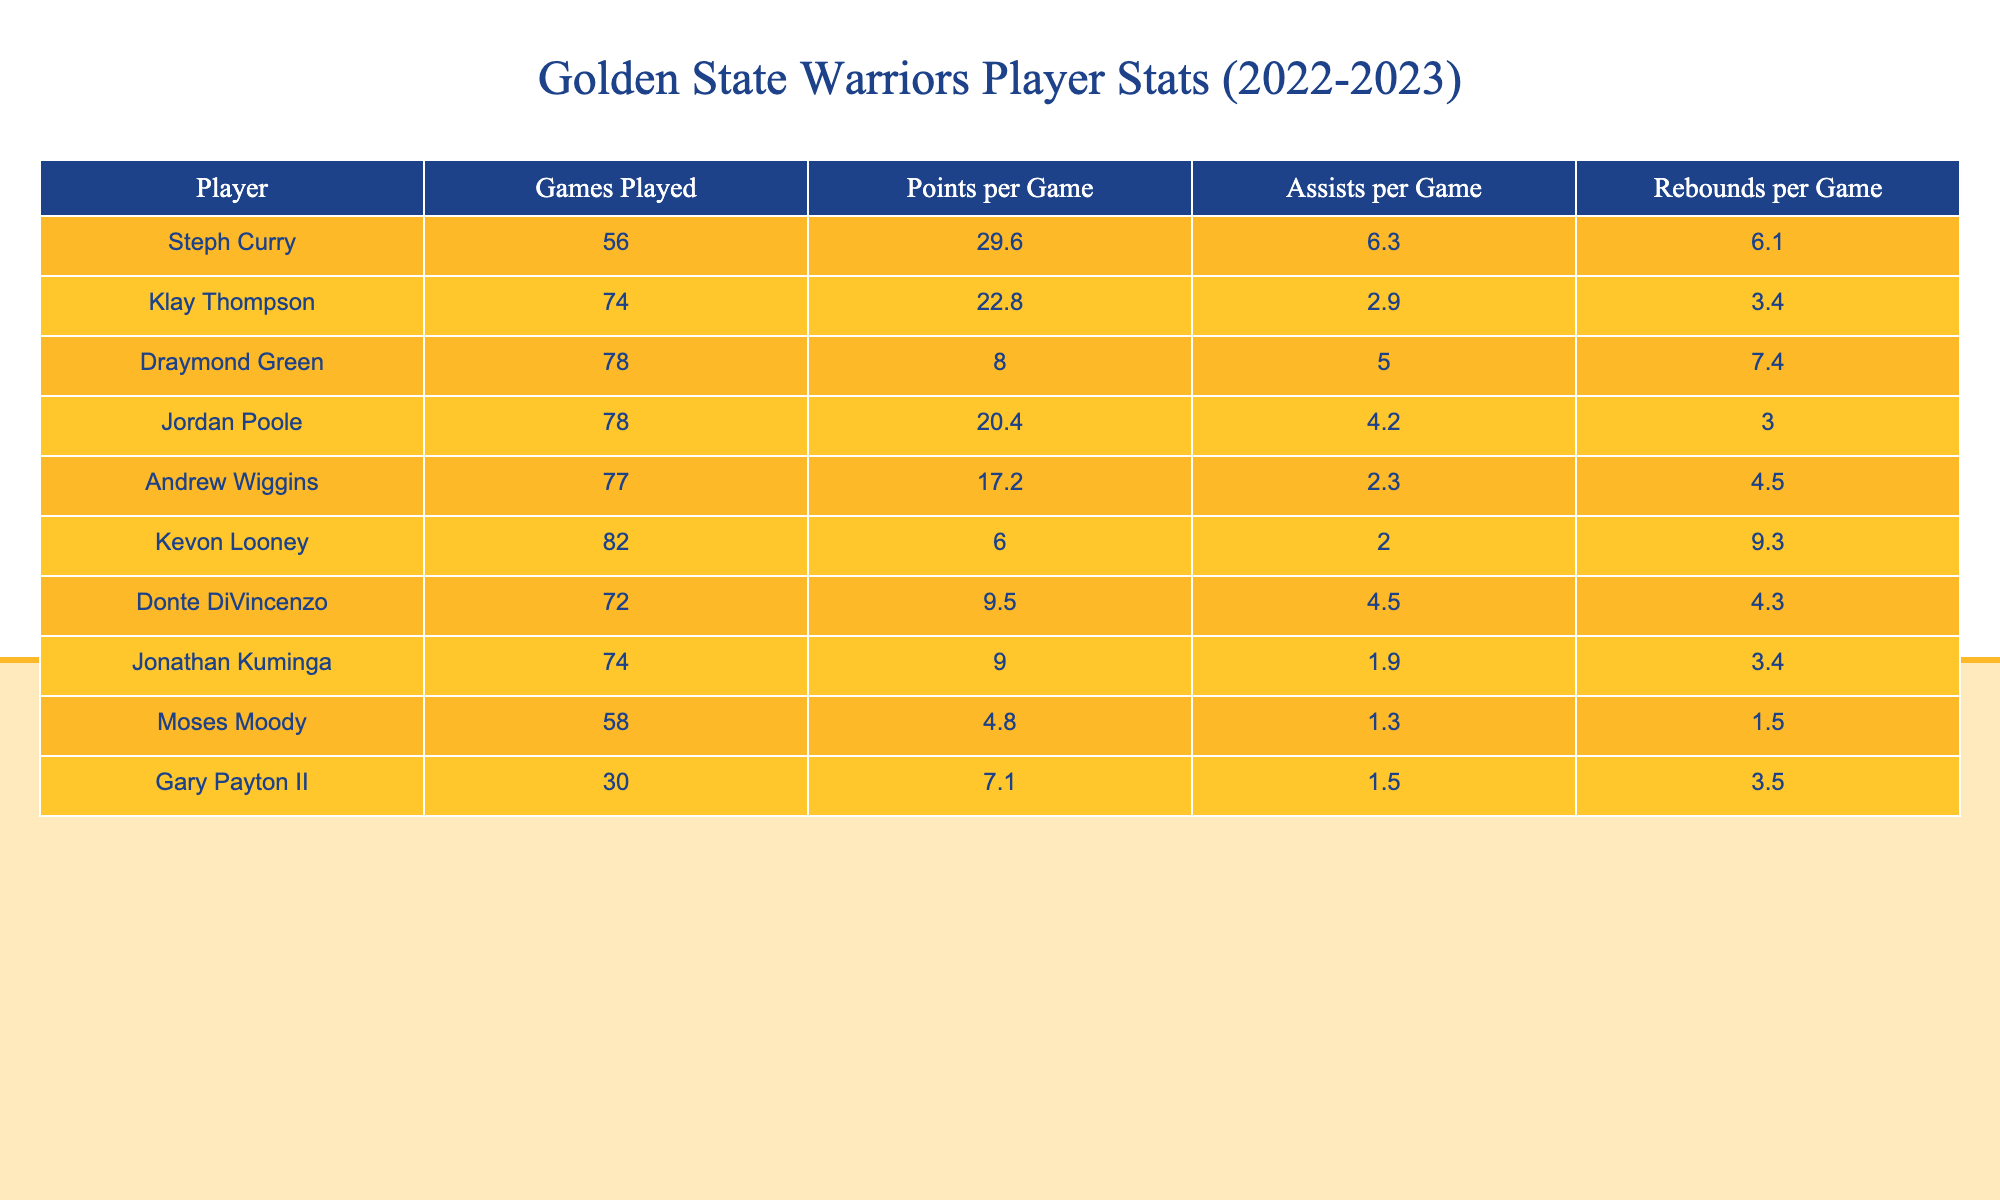What is Steph Curry's points per game during the 2022-2023 season? By looking at the table, Steph Curry's points per game is listed in the corresponding row under the "Points per Game" column. The value is 29.6.
Answer: 29.6 How many games did Klay Thompson play in the 2022-2023 season? In the table, Klay Thompson's row shows the number of games played under the "Games Played" column. The value is 74.
Answer: 74 Who had the highest assists per game in the season? To find the player with the highest assists per game, we compare the values in the "Assists per Game" column. Steph Curry has 6.3, which is the highest compared to others.
Answer: Steph Curry What is the average points per game for the Warriors players listed in the table? We first add all the points per game together: 29.6 + 22.8 + 8.0 + 20.4 + 17.2 + 6.0 + 9.5 + 9.0 + 4.8 + 7.1 =  129.6. Then, we divide by the number of players (10): 129.6 / 10 = 12.96.
Answer: 12.96 Does Donte DiVincenzo have more rebounds per game than Jordan Poole? We compare the "Rebounds per Game" values for both players. Donte DiVincenzo has 4.3, while Jordan Poole has 3.0, so Donte DiVincenzo has more.
Answer: Yes What is the total number of rebounds per game for all players listed? We sum the rebounds per game values: 6.1 + 3.4 + 7.4 + 3.0 + 4.5 + 9.3 + 4.3 + 3.4 + 1.5 + 3.5 = 46.0.
Answer: 46.0 Which player had the lowest points per game? By inspecting the "Points per Game" column, Moses Moody has the lowest value of 4.8.
Answer: Moses Moody What is the difference in assists per game between Steph Curry and Draymond Green? We subtract Draymond Green's assists per game (5.0) from Steph Curry's (6.3) to find the difference: 6.3 - 5.0 = 1.3.
Answer: 1.3 How many players scored more than 20 points per game? We look at the "Points per Game" column and see that Steph Curry and Klay Thompson both scored more than 20 points per game, making it 2 players.
Answer: 2 If you combine the points per game for Andrew Wiggins and Jordan Poole, what is the total? Adding their points per game: Andrew Wiggins (17.2) + Jordan Poole (20.4) = 37.6.
Answer: 37.6 